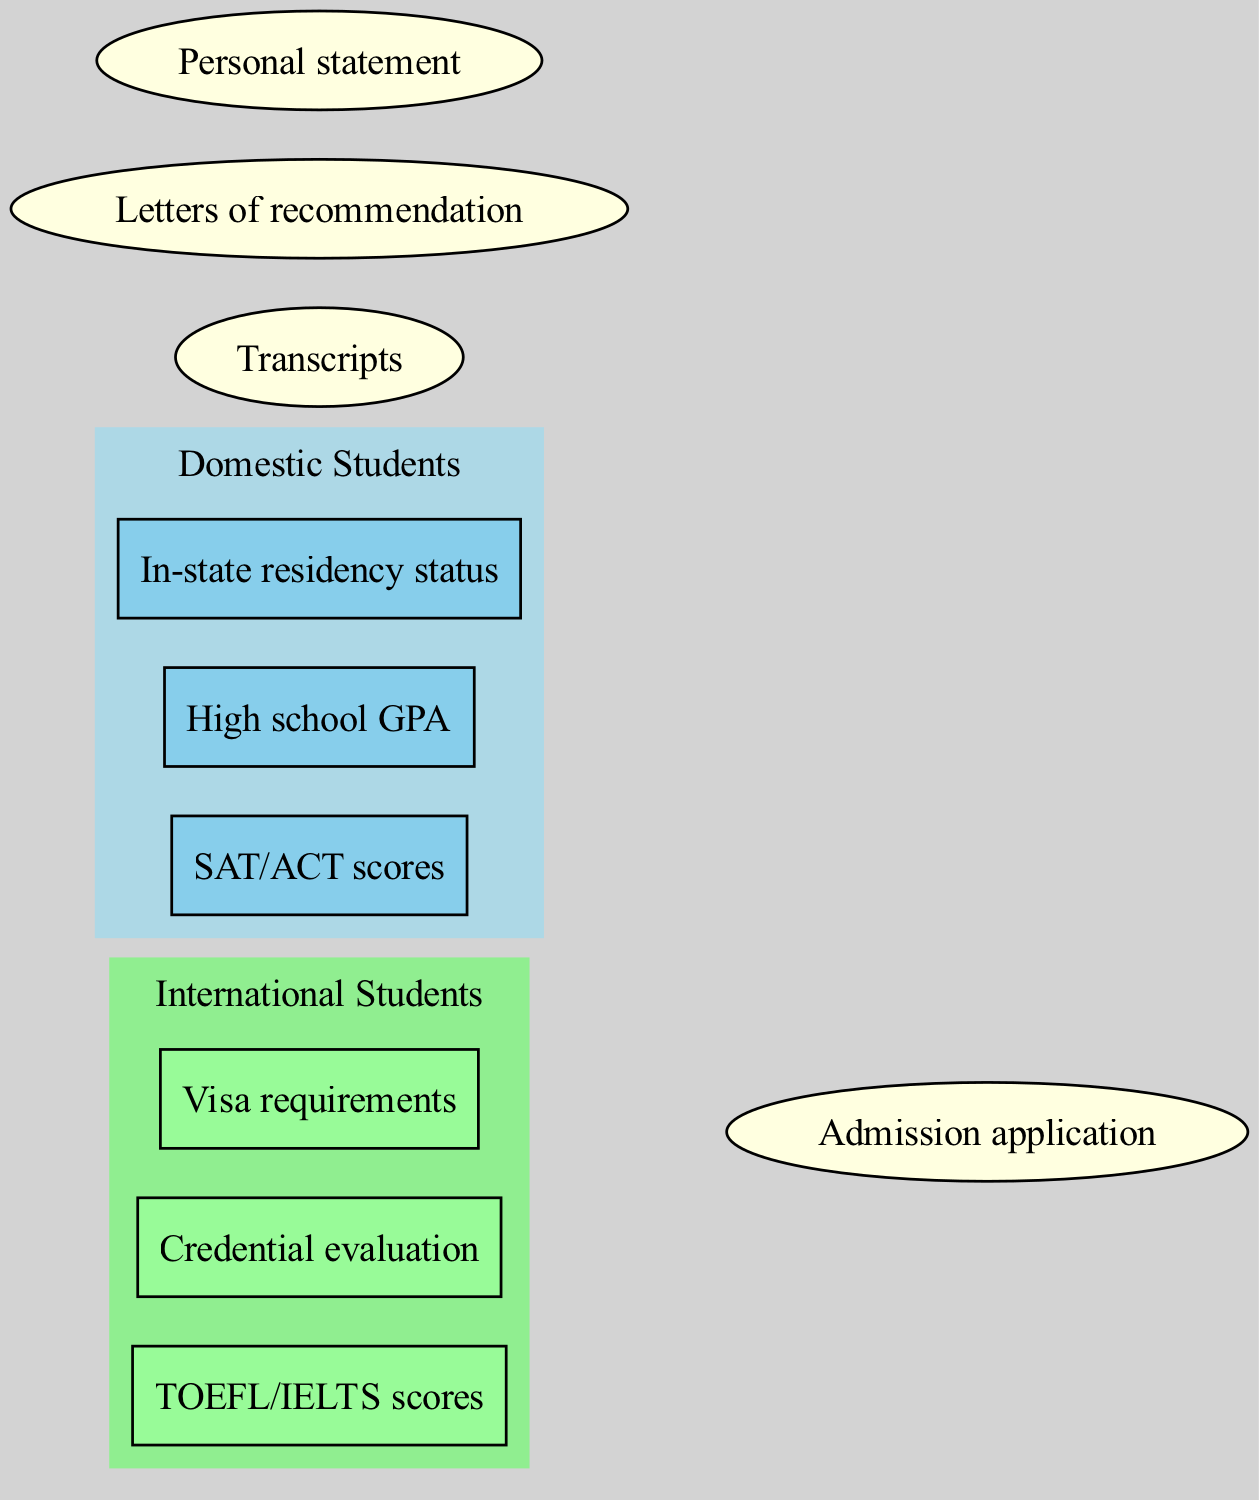What are the academic requirements for domestic students? The diagram indicates that the academic requirements specific to domestic students include SAT/ACT scores, High school GPA, and In-state residency status. These components are located within the "Domestic Students" set in the diagram.
Answer: SAT/ACT scores, High school GPA, In-state residency status How many elements are unique to international students? The diagram lists three unique elements in the "International Students" set: TOEFL/IELTS scores, Credential evaluation, and Visa requirements. There are no overlap elements in this set that are not common requirements.
Answer: 3 What is a common requirement for both domestic and international students? The common requirements section contains Admission application, Transcripts, Letters of recommendation, and Personal statement. These elements are represented as ellipses in the shared area of the diagram.
Answer: Admission application, Transcripts, Letters of recommendation, Personal statement Which score is required for international students? According to the diagram, international students are specifically required to present TOEFL/IELTS scores. This is located in the "International Students" set.
Answer: TOEFL/IELTS scores Is there any overlap between domestic and international students' academic requirements? The diagram reveals that both groups share common requirements outlined in the intersecting area. While there are no unique requirements that overlap, the common elements suggest that both groups must meet similar standards for admission.
Answer: Yes What are the unique components needed only by domestic students? The diagram shows that the unique components for domestic students are SAT/ACT scores, High school GPA, and In-state residency status. These elements are solely associated with domestic students and do not appear elsewhere.
Answer: SAT/ACT scores, High school GPA, In-state residency status Which component signifies immigration status for international students? The component in the "International Students" set that signifies immigration status is Visa requirements. It indicates a need for complying with legal immigration standards to study in a different country.
Answer: Visa requirements How many total unique requirements are there for both student categories combined? The unique academic requirements for domestic students total three, while international students have three as well. Adding these to the four common requirements gives a total of 10 unique academic requirements when both categories are considered together.
Answer: 10 